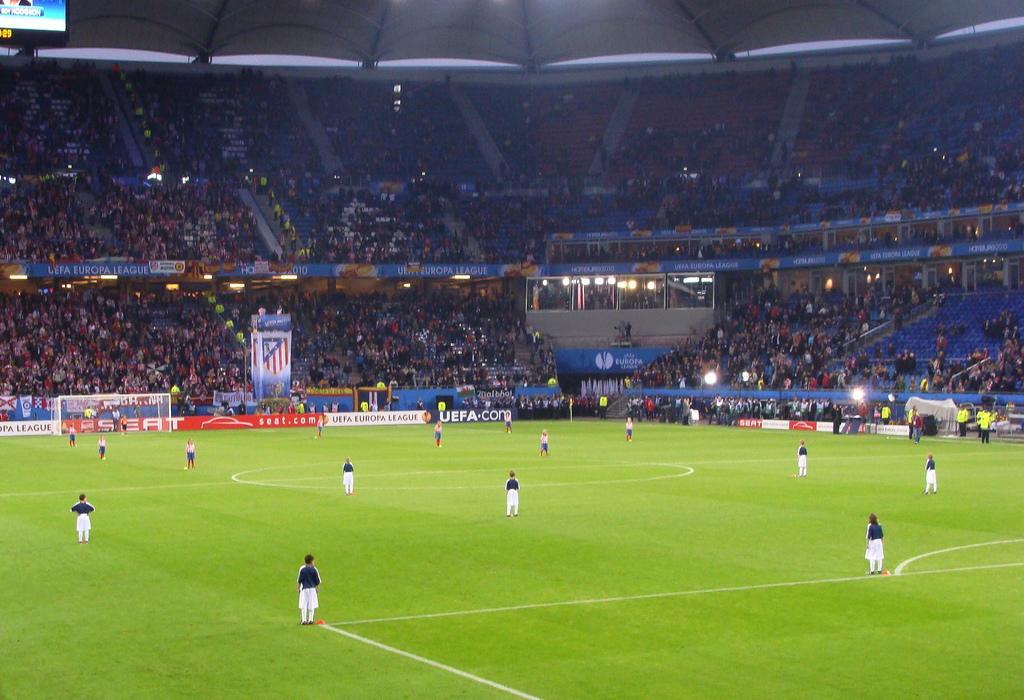Can you describe this image briefly? In this picture we can see some people are standing on the ground. There are few posters from left to right. We can see crowd in the background. There is a screen on top left. 